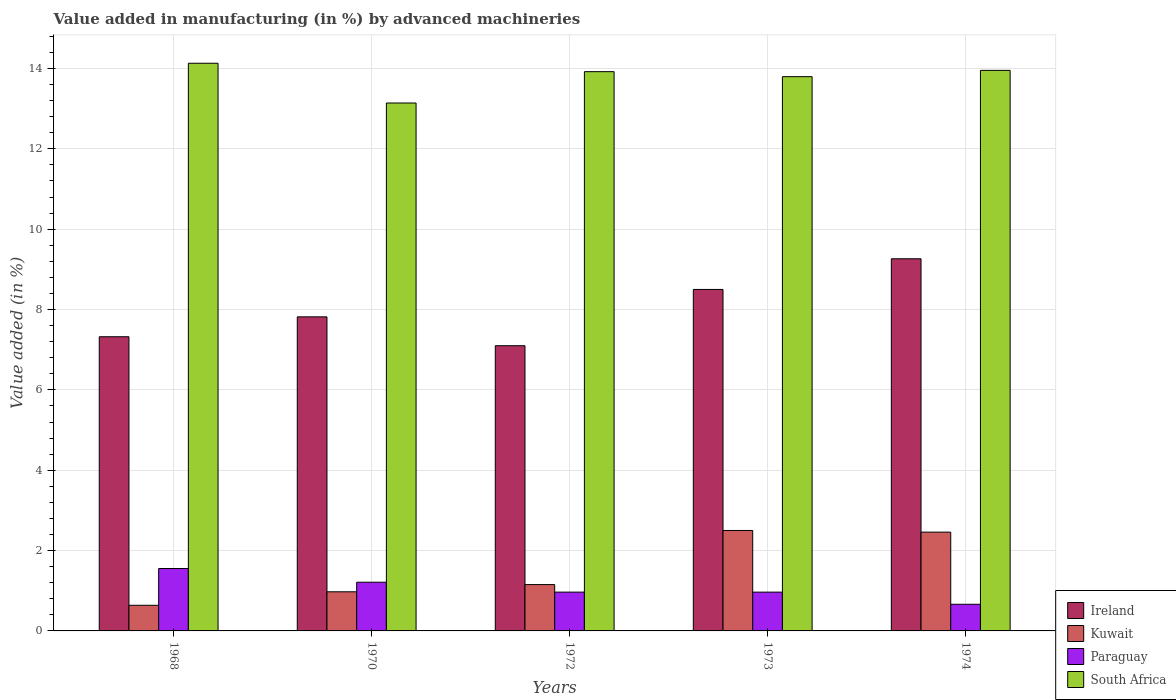How many different coloured bars are there?
Give a very brief answer. 4. Are the number of bars per tick equal to the number of legend labels?
Your answer should be very brief. Yes. How many bars are there on the 4th tick from the right?
Provide a short and direct response. 4. What is the label of the 2nd group of bars from the left?
Your answer should be very brief. 1970. What is the percentage of value added in manufacturing by advanced machineries in Ireland in 1974?
Give a very brief answer. 9.26. Across all years, what is the maximum percentage of value added in manufacturing by advanced machineries in Kuwait?
Offer a very short reply. 2.5. Across all years, what is the minimum percentage of value added in manufacturing by advanced machineries in Kuwait?
Offer a terse response. 0.64. In which year was the percentage of value added in manufacturing by advanced machineries in Paraguay maximum?
Ensure brevity in your answer.  1968. What is the total percentage of value added in manufacturing by advanced machineries in Kuwait in the graph?
Make the answer very short. 7.73. What is the difference between the percentage of value added in manufacturing by advanced machineries in Paraguay in 1968 and that in 1973?
Ensure brevity in your answer.  0.59. What is the difference between the percentage of value added in manufacturing by advanced machineries in Paraguay in 1968 and the percentage of value added in manufacturing by advanced machineries in Kuwait in 1970?
Ensure brevity in your answer.  0.58. What is the average percentage of value added in manufacturing by advanced machineries in Ireland per year?
Give a very brief answer. 8. In the year 1968, what is the difference between the percentage of value added in manufacturing by advanced machineries in Kuwait and percentage of value added in manufacturing by advanced machineries in Ireland?
Give a very brief answer. -6.68. In how many years, is the percentage of value added in manufacturing by advanced machineries in Paraguay greater than 8.8 %?
Your answer should be very brief. 0. What is the ratio of the percentage of value added in manufacturing by advanced machineries in Kuwait in 1970 to that in 1974?
Provide a succinct answer. 0.4. What is the difference between the highest and the second highest percentage of value added in manufacturing by advanced machineries in Paraguay?
Your answer should be very brief. 0.34. What is the difference between the highest and the lowest percentage of value added in manufacturing by advanced machineries in Paraguay?
Your answer should be very brief. 0.89. In how many years, is the percentage of value added in manufacturing by advanced machineries in Kuwait greater than the average percentage of value added in manufacturing by advanced machineries in Kuwait taken over all years?
Keep it short and to the point. 2. Is it the case that in every year, the sum of the percentage of value added in manufacturing by advanced machineries in South Africa and percentage of value added in manufacturing by advanced machineries in Kuwait is greater than the sum of percentage of value added in manufacturing by advanced machineries in Ireland and percentage of value added in manufacturing by advanced machineries in Paraguay?
Offer a very short reply. No. What does the 4th bar from the left in 1970 represents?
Offer a terse response. South Africa. What does the 1st bar from the right in 1973 represents?
Your response must be concise. South Africa. Is it the case that in every year, the sum of the percentage of value added in manufacturing by advanced machineries in Kuwait and percentage of value added in manufacturing by advanced machineries in Ireland is greater than the percentage of value added in manufacturing by advanced machineries in South Africa?
Ensure brevity in your answer.  No. Does the graph contain any zero values?
Provide a short and direct response. No. Does the graph contain grids?
Ensure brevity in your answer.  Yes. How many legend labels are there?
Keep it short and to the point. 4. What is the title of the graph?
Provide a short and direct response. Value added in manufacturing (in %) by advanced machineries. What is the label or title of the Y-axis?
Offer a very short reply. Value added (in %). What is the Value added (in %) in Ireland in 1968?
Keep it short and to the point. 7.32. What is the Value added (in %) of Kuwait in 1968?
Offer a terse response. 0.64. What is the Value added (in %) of Paraguay in 1968?
Offer a terse response. 1.55. What is the Value added (in %) of South Africa in 1968?
Your response must be concise. 14.13. What is the Value added (in %) of Ireland in 1970?
Give a very brief answer. 7.82. What is the Value added (in %) of Kuwait in 1970?
Give a very brief answer. 0.97. What is the Value added (in %) of Paraguay in 1970?
Keep it short and to the point. 1.21. What is the Value added (in %) in South Africa in 1970?
Keep it short and to the point. 13.14. What is the Value added (in %) of Ireland in 1972?
Ensure brevity in your answer.  7.1. What is the Value added (in %) of Kuwait in 1972?
Keep it short and to the point. 1.15. What is the Value added (in %) of Paraguay in 1972?
Keep it short and to the point. 0.97. What is the Value added (in %) in South Africa in 1972?
Offer a very short reply. 13.92. What is the Value added (in %) in Ireland in 1973?
Ensure brevity in your answer.  8.5. What is the Value added (in %) in Kuwait in 1973?
Provide a succinct answer. 2.5. What is the Value added (in %) of Paraguay in 1973?
Keep it short and to the point. 0.97. What is the Value added (in %) of South Africa in 1973?
Your answer should be very brief. 13.8. What is the Value added (in %) in Ireland in 1974?
Offer a very short reply. 9.26. What is the Value added (in %) of Kuwait in 1974?
Make the answer very short. 2.46. What is the Value added (in %) in Paraguay in 1974?
Your answer should be compact. 0.66. What is the Value added (in %) of South Africa in 1974?
Your response must be concise. 13.95. Across all years, what is the maximum Value added (in %) of Ireland?
Your answer should be very brief. 9.26. Across all years, what is the maximum Value added (in %) of Kuwait?
Keep it short and to the point. 2.5. Across all years, what is the maximum Value added (in %) in Paraguay?
Give a very brief answer. 1.55. Across all years, what is the maximum Value added (in %) in South Africa?
Provide a short and direct response. 14.13. Across all years, what is the minimum Value added (in %) in Ireland?
Ensure brevity in your answer.  7.1. Across all years, what is the minimum Value added (in %) in Kuwait?
Give a very brief answer. 0.64. Across all years, what is the minimum Value added (in %) of Paraguay?
Provide a succinct answer. 0.66. Across all years, what is the minimum Value added (in %) in South Africa?
Offer a very short reply. 13.14. What is the total Value added (in %) of Ireland in the graph?
Make the answer very short. 40. What is the total Value added (in %) of Kuwait in the graph?
Keep it short and to the point. 7.72. What is the total Value added (in %) in Paraguay in the graph?
Make the answer very short. 5.36. What is the total Value added (in %) in South Africa in the graph?
Your answer should be very brief. 68.94. What is the difference between the Value added (in %) in Ireland in 1968 and that in 1970?
Keep it short and to the point. -0.5. What is the difference between the Value added (in %) in Kuwait in 1968 and that in 1970?
Provide a succinct answer. -0.34. What is the difference between the Value added (in %) in Paraguay in 1968 and that in 1970?
Make the answer very short. 0.34. What is the difference between the Value added (in %) of South Africa in 1968 and that in 1970?
Give a very brief answer. 0.99. What is the difference between the Value added (in %) in Ireland in 1968 and that in 1972?
Your answer should be very brief. 0.22. What is the difference between the Value added (in %) of Kuwait in 1968 and that in 1972?
Your response must be concise. -0.52. What is the difference between the Value added (in %) in Paraguay in 1968 and that in 1972?
Provide a short and direct response. 0.59. What is the difference between the Value added (in %) of South Africa in 1968 and that in 1972?
Make the answer very short. 0.21. What is the difference between the Value added (in %) in Ireland in 1968 and that in 1973?
Your response must be concise. -1.18. What is the difference between the Value added (in %) of Kuwait in 1968 and that in 1973?
Offer a terse response. -1.86. What is the difference between the Value added (in %) in Paraguay in 1968 and that in 1973?
Make the answer very short. 0.59. What is the difference between the Value added (in %) of South Africa in 1968 and that in 1973?
Ensure brevity in your answer.  0.33. What is the difference between the Value added (in %) of Ireland in 1968 and that in 1974?
Your answer should be very brief. -1.94. What is the difference between the Value added (in %) of Kuwait in 1968 and that in 1974?
Keep it short and to the point. -1.82. What is the difference between the Value added (in %) in Paraguay in 1968 and that in 1974?
Your answer should be very brief. 0.89. What is the difference between the Value added (in %) in South Africa in 1968 and that in 1974?
Provide a short and direct response. 0.18. What is the difference between the Value added (in %) in Ireland in 1970 and that in 1972?
Offer a terse response. 0.72. What is the difference between the Value added (in %) of Kuwait in 1970 and that in 1972?
Your answer should be compact. -0.18. What is the difference between the Value added (in %) of Paraguay in 1970 and that in 1972?
Make the answer very short. 0.25. What is the difference between the Value added (in %) of South Africa in 1970 and that in 1972?
Ensure brevity in your answer.  -0.78. What is the difference between the Value added (in %) of Ireland in 1970 and that in 1973?
Make the answer very short. -0.68. What is the difference between the Value added (in %) of Kuwait in 1970 and that in 1973?
Your response must be concise. -1.53. What is the difference between the Value added (in %) of Paraguay in 1970 and that in 1973?
Offer a very short reply. 0.25. What is the difference between the Value added (in %) of South Africa in 1970 and that in 1973?
Provide a succinct answer. -0.66. What is the difference between the Value added (in %) in Ireland in 1970 and that in 1974?
Ensure brevity in your answer.  -1.45. What is the difference between the Value added (in %) of Kuwait in 1970 and that in 1974?
Your answer should be very brief. -1.49. What is the difference between the Value added (in %) of Paraguay in 1970 and that in 1974?
Give a very brief answer. 0.55. What is the difference between the Value added (in %) in South Africa in 1970 and that in 1974?
Offer a very short reply. -0.81. What is the difference between the Value added (in %) of Ireland in 1972 and that in 1973?
Offer a terse response. -1.4. What is the difference between the Value added (in %) in Kuwait in 1972 and that in 1973?
Your response must be concise. -1.35. What is the difference between the Value added (in %) of Paraguay in 1972 and that in 1973?
Your response must be concise. 0. What is the difference between the Value added (in %) of South Africa in 1972 and that in 1973?
Your answer should be compact. 0.12. What is the difference between the Value added (in %) in Ireland in 1972 and that in 1974?
Offer a very short reply. -2.16. What is the difference between the Value added (in %) of Kuwait in 1972 and that in 1974?
Your answer should be compact. -1.31. What is the difference between the Value added (in %) in Paraguay in 1972 and that in 1974?
Your response must be concise. 0.3. What is the difference between the Value added (in %) of South Africa in 1972 and that in 1974?
Offer a very short reply. -0.03. What is the difference between the Value added (in %) of Ireland in 1973 and that in 1974?
Provide a succinct answer. -0.76. What is the difference between the Value added (in %) in Kuwait in 1973 and that in 1974?
Provide a short and direct response. 0.04. What is the difference between the Value added (in %) of Paraguay in 1973 and that in 1974?
Keep it short and to the point. 0.3. What is the difference between the Value added (in %) in South Africa in 1973 and that in 1974?
Keep it short and to the point. -0.16. What is the difference between the Value added (in %) in Ireland in 1968 and the Value added (in %) in Kuwait in 1970?
Keep it short and to the point. 6.35. What is the difference between the Value added (in %) of Ireland in 1968 and the Value added (in %) of Paraguay in 1970?
Offer a very short reply. 6.11. What is the difference between the Value added (in %) in Ireland in 1968 and the Value added (in %) in South Africa in 1970?
Offer a very short reply. -5.82. What is the difference between the Value added (in %) in Kuwait in 1968 and the Value added (in %) in Paraguay in 1970?
Your answer should be compact. -0.57. What is the difference between the Value added (in %) of Kuwait in 1968 and the Value added (in %) of South Africa in 1970?
Ensure brevity in your answer.  -12.5. What is the difference between the Value added (in %) of Paraguay in 1968 and the Value added (in %) of South Africa in 1970?
Make the answer very short. -11.59. What is the difference between the Value added (in %) in Ireland in 1968 and the Value added (in %) in Kuwait in 1972?
Your answer should be compact. 6.17. What is the difference between the Value added (in %) of Ireland in 1968 and the Value added (in %) of Paraguay in 1972?
Ensure brevity in your answer.  6.36. What is the difference between the Value added (in %) of Ireland in 1968 and the Value added (in %) of South Africa in 1972?
Offer a very short reply. -6.6. What is the difference between the Value added (in %) of Kuwait in 1968 and the Value added (in %) of Paraguay in 1972?
Your answer should be very brief. -0.33. What is the difference between the Value added (in %) of Kuwait in 1968 and the Value added (in %) of South Africa in 1972?
Offer a terse response. -13.28. What is the difference between the Value added (in %) of Paraguay in 1968 and the Value added (in %) of South Africa in 1972?
Keep it short and to the point. -12.37. What is the difference between the Value added (in %) of Ireland in 1968 and the Value added (in %) of Kuwait in 1973?
Your answer should be very brief. 4.82. What is the difference between the Value added (in %) in Ireland in 1968 and the Value added (in %) in Paraguay in 1973?
Provide a short and direct response. 6.36. What is the difference between the Value added (in %) in Ireland in 1968 and the Value added (in %) in South Africa in 1973?
Your answer should be very brief. -6.47. What is the difference between the Value added (in %) in Kuwait in 1968 and the Value added (in %) in Paraguay in 1973?
Ensure brevity in your answer.  -0.33. What is the difference between the Value added (in %) in Kuwait in 1968 and the Value added (in %) in South Africa in 1973?
Provide a succinct answer. -13.16. What is the difference between the Value added (in %) in Paraguay in 1968 and the Value added (in %) in South Africa in 1973?
Provide a short and direct response. -12.24. What is the difference between the Value added (in %) of Ireland in 1968 and the Value added (in %) of Kuwait in 1974?
Your response must be concise. 4.86. What is the difference between the Value added (in %) of Ireland in 1968 and the Value added (in %) of Paraguay in 1974?
Your answer should be compact. 6.66. What is the difference between the Value added (in %) in Ireland in 1968 and the Value added (in %) in South Africa in 1974?
Make the answer very short. -6.63. What is the difference between the Value added (in %) in Kuwait in 1968 and the Value added (in %) in Paraguay in 1974?
Offer a terse response. -0.03. What is the difference between the Value added (in %) in Kuwait in 1968 and the Value added (in %) in South Africa in 1974?
Provide a short and direct response. -13.31. What is the difference between the Value added (in %) of Paraguay in 1968 and the Value added (in %) of South Africa in 1974?
Provide a short and direct response. -12.4. What is the difference between the Value added (in %) in Ireland in 1970 and the Value added (in %) in Kuwait in 1972?
Offer a very short reply. 6.66. What is the difference between the Value added (in %) in Ireland in 1970 and the Value added (in %) in Paraguay in 1972?
Your response must be concise. 6.85. What is the difference between the Value added (in %) in Ireland in 1970 and the Value added (in %) in South Africa in 1972?
Ensure brevity in your answer.  -6.1. What is the difference between the Value added (in %) in Kuwait in 1970 and the Value added (in %) in Paraguay in 1972?
Your answer should be compact. 0.01. What is the difference between the Value added (in %) of Kuwait in 1970 and the Value added (in %) of South Africa in 1972?
Provide a short and direct response. -12.95. What is the difference between the Value added (in %) in Paraguay in 1970 and the Value added (in %) in South Africa in 1972?
Your response must be concise. -12.71. What is the difference between the Value added (in %) in Ireland in 1970 and the Value added (in %) in Kuwait in 1973?
Make the answer very short. 5.32. What is the difference between the Value added (in %) of Ireland in 1970 and the Value added (in %) of Paraguay in 1973?
Your answer should be very brief. 6.85. What is the difference between the Value added (in %) in Ireland in 1970 and the Value added (in %) in South Africa in 1973?
Your answer should be very brief. -5.98. What is the difference between the Value added (in %) in Kuwait in 1970 and the Value added (in %) in Paraguay in 1973?
Offer a terse response. 0.01. What is the difference between the Value added (in %) in Kuwait in 1970 and the Value added (in %) in South Africa in 1973?
Give a very brief answer. -12.82. What is the difference between the Value added (in %) of Paraguay in 1970 and the Value added (in %) of South Africa in 1973?
Provide a short and direct response. -12.58. What is the difference between the Value added (in %) of Ireland in 1970 and the Value added (in %) of Kuwait in 1974?
Offer a very short reply. 5.36. What is the difference between the Value added (in %) in Ireland in 1970 and the Value added (in %) in Paraguay in 1974?
Your response must be concise. 7.15. What is the difference between the Value added (in %) of Ireland in 1970 and the Value added (in %) of South Africa in 1974?
Make the answer very short. -6.13. What is the difference between the Value added (in %) of Kuwait in 1970 and the Value added (in %) of Paraguay in 1974?
Give a very brief answer. 0.31. What is the difference between the Value added (in %) in Kuwait in 1970 and the Value added (in %) in South Africa in 1974?
Ensure brevity in your answer.  -12.98. What is the difference between the Value added (in %) in Paraguay in 1970 and the Value added (in %) in South Africa in 1974?
Offer a very short reply. -12.74. What is the difference between the Value added (in %) of Ireland in 1972 and the Value added (in %) of Kuwait in 1973?
Your answer should be compact. 4.6. What is the difference between the Value added (in %) in Ireland in 1972 and the Value added (in %) in Paraguay in 1973?
Make the answer very short. 6.13. What is the difference between the Value added (in %) of Ireland in 1972 and the Value added (in %) of South Africa in 1973?
Provide a succinct answer. -6.7. What is the difference between the Value added (in %) of Kuwait in 1972 and the Value added (in %) of Paraguay in 1973?
Ensure brevity in your answer.  0.19. What is the difference between the Value added (in %) in Kuwait in 1972 and the Value added (in %) in South Africa in 1973?
Provide a short and direct response. -12.64. What is the difference between the Value added (in %) in Paraguay in 1972 and the Value added (in %) in South Africa in 1973?
Offer a very short reply. -12.83. What is the difference between the Value added (in %) of Ireland in 1972 and the Value added (in %) of Kuwait in 1974?
Your response must be concise. 4.64. What is the difference between the Value added (in %) of Ireland in 1972 and the Value added (in %) of Paraguay in 1974?
Your answer should be very brief. 6.44. What is the difference between the Value added (in %) in Ireland in 1972 and the Value added (in %) in South Africa in 1974?
Your answer should be compact. -6.85. What is the difference between the Value added (in %) of Kuwait in 1972 and the Value added (in %) of Paraguay in 1974?
Your answer should be very brief. 0.49. What is the difference between the Value added (in %) in Kuwait in 1972 and the Value added (in %) in South Africa in 1974?
Keep it short and to the point. -12.8. What is the difference between the Value added (in %) in Paraguay in 1972 and the Value added (in %) in South Africa in 1974?
Offer a very short reply. -12.99. What is the difference between the Value added (in %) in Ireland in 1973 and the Value added (in %) in Kuwait in 1974?
Make the answer very short. 6.04. What is the difference between the Value added (in %) of Ireland in 1973 and the Value added (in %) of Paraguay in 1974?
Your answer should be very brief. 7.84. What is the difference between the Value added (in %) of Ireland in 1973 and the Value added (in %) of South Africa in 1974?
Make the answer very short. -5.45. What is the difference between the Value added (in %) in Kuwait in 1973 and the Value added (in %) in Paraguay in 1974?
Provide a succinct answer. 1.84. What is the difference between the Value added (in %) in Kuwait in 1973 and the Value added (in %) in South Africa in 1974?
Provide a short and direct response. -11.45. What is the difference between the Value added (in %) in Paraguay in 1973 and the Value added (in %) in South Africa in 1974?
Provide a short and direct response. -12.99. What is the average Value added (in %) in Ireland per year?
Your answer should be very brief. 8. What is the average Value added (in %) of Kuwait per year?
Your response must be concise. 1.54. What is the average Value added (in %) of Paraguay per year?
Make the answer very short. 1.07. What is the average Value added (in %) of South Africa per year?
Your response must be concise. 13.79. In the year 1968, what is the difference between the Value added (in %) in Ireland and Value added (in %) in Kuwait?
Your answer should be compact. 6.68. In the year 1968, what is the difference between the Value added (in %) in Ireland and Value added (in %) in Paraguay?
Give a very brief answer. 5.77. In the year 1968, what is the difference between the Value added (in %) of Ireland and Value added (in %) of South Africa?
Your response must be concise. -6.81. In the year 1968, what is the difference between the Value added (in %) of Kuwait and Value added (in %) of Paraguay?
Provide a succinct answer. -0.92. In the year 1968, what is the difference between the Value added (in %) in Kuwait and Value added (in %) in South Africa?
Your answer should be compact. -13.49. In the year 1968, what is the difference between the Value added (in %) of Paraguay and Value added (in %) of South Africa?
Your answer should be compact. -12.58. In the year 1970, what is the difference between the Value added (in %) in Ireland and Value added (in %) in Kuwait?
Provide a short and direct response. 6.84. In the year 1970, what is the difference between the Value added (in %) in Ireland and Value added (in %) in Paraguay?
Provide a short and direct response. 6.61. In the year 1970, what is the difference between the Value added (in %) in Ireland and Value added (in %) in South Africa?
Offer a terse response. -5.32. In the year 1970, what is the difference between the Value added (in %) of Kuwait and Value added (in %) of Paraguay?
Give a very brief answer. -0.24. In the year 1970, what is the difference between the Value added (in %) of Kuwait and Value added (in %) of South Africa?
Keep it short and to the point. -12.17. In the year 1970, what is the difference between the Value added (in %) in Paraguay and Value added (in %) in South Africa?
Offer a very short reply. -11.93. In the year 1972, what is the difference between the Value added (in %) in Ireland and Value added (in %) in Kuwait?
Offer a terse response. 5.95. In the year 1972, what is the difference between the Value added (in %) in Ireland and Value added (in %) in Paraguay?
Your answer should be very brief. 6.13. In the year 1972, what is the difference between the Value added (in %) in Ireland and Value added (in %) in South Africa?
Your response must be concise. -6.82. In the year 1972, what is the difference between the Value added (in %) of Kuwait and Value added (in %) of Paraguay?
Make the answer very short. 0.19. In the year 1972, what is the difference between the Value added (in %) in Kuwait and Value added (in %) in South Africa?
Your answer should be compact. -12.77. In the year 1972, what is the difference between the Value added (in %) of Paraguay and Value added (in %) of South Africa?
Provide a short and direct response. -12.95. In the year 1973, what is the difference between the Value added (in %) in Ireland and Value added (in %) in Kuwait?
Offer a terse response. 6. In the year 1973, what is the difference between the Value added (in %) of Ireland and Value added (in %) of Paraguay?
Your response must be concise. 7.53. In the year 1973, what is the difference between the Value added (in %) of Ireland and Value added (in %) of South Africa?
Give a very brief answer. -5.3. In the year 1973, what is the difference between the Value added (in %) of Kuwait and Value added (in %) of Paraguay?
Ensure brevity in your answer.  1.53. In the year 1973, what is the difference between the Value added (in %) in Kuwait and Value added (in %) in South Africa?
Offer a very short reply. -11.3. In the year 1973, what is the difference between the Value added (in %) in Paraguay and Value added (in %) in South Africa?
Provide a short and direct response. -12.83. In the year 1974, what is the difference between the Value added (in %) of Ireland and Value added (in %) of Kuwait?
Ensure brevity in your answer.  6.8. In the year 1974, what is the difference between the Value added (in %) of Ireland and Value added (in %) of Paraguay?
Ensure brevity in your answer.  8.6. In the year 1974, what is the difference between the Value added (in %) in Ireland and Value added (in %) in South Africa?
Give a very brief answer. -4.69. In the year 1974, what is the difference between the Value added (in %) in Kuwait and Value added (in %) in Paraguay?
Your answer should be very brief. 1.8. In the year 1974, what is the difference between the Value added (in %) in Kuwait and Value added (in %) in South Africa?
Provide a succinct answer. -11.49. In the year 1974, what is the difference between the Value added (in %) in Paraguay and Value added (in %) in South Africa?
Offer a very short reply. -13.29. What is the ratio of the Value added (in %) in Ireland in 1968 to that in 1970?
Offer a very short reply. 0.94. What is the ratio of the Value added (in %) in Kuwait in 1968 to that in 1970?
Your response must be concise. 0.66. What is the ratio of the Value added (in %) of Paraguay in 1968 to that in 1970?
Give a very brief answer. 1.28. What is the ratio of the Value added (in %) of South Africa in 1968 to that in 1970?
Your answer should be compact. 1.08. What is the ratio of the Value added (in %) of Ireland in 1968 to that in 1972?
Your answer should be very brief. 1.03. What is the ratio of the Value added (in %) of Kuwait in 1968 to that in 1972?
Provide a short and direct response. 0.55. What is the ratio of the Value added (in %) in Paraguay in 1968 to that in 1972?
Offer a very short reply. 1.61. What is the ratio of the Value added (in %) in South Africa in 1968 to that in 1972?
Your answer should be very brief. 1.01. What is the ratio of the Value added (in %) of Ireland in 1968 to that in 1973?
Your response must be concise. 0.86. What is the ratio of the Value added (in %) of Kuwait in 1968 to that in 1973?
Provide a succinct answer. 0.26. What is the ratio of the Value added (in %) of Paraguay in 1968 to that in 1973?
Offer a very short reply. 1.61. What is the ratio of the Value added (in %) of South Africa in 1968 to that in 1973?
Make the answer very short. 1.02. What is the ratio of the Value added (in %) of Ireland in 1968 to that in 1974?
Your answer should be compact. 0.79. What is the ratio of the Value added (in %) in Kuwait in 1968 to that in 1974?
Provide a succinct answer. 0.26. What is the ratio of the Value added (in %) of Paraguay in 1968 to that in 1974?
Give a very brief answer. 2.34. What is the ratio of the Value added (in %) of South Africa in 1968 to that in 1974?
Keep it short and to the point. 1.01. What is the ratio of the Value added (in %) of Ireland in 1970 to that in 1972?
Your response must be concise. 1.1. What is the ratio of the Value added (in %) of Kuwait in 1970 to that in 1972?
Keep it short and to the point. 0.84. What is the ratio of the Value added (in %) of Paraguay in 1970 to that in 1972?
Ensure brevity in your answer.  1.26. What is the ratio of the Value added (in %) of South Africa in 1970 to that in 1972?
Keep it short and to the point. 0.94. What is the ratio of the Value added (in %) in Ireland in 1970 to that in 1973?
Your answer should be compact. 0.92. What is the ratio of the Value added (in %) of Kuwait in 1970 to that in 1973?
Ensure brevity in your answer.  0.39. What is the ratio of the Value added (in %) of Paraguay in 1970 to that in 1973?
Provide a succinct answer. 1.26. What is the ratio of the Value added (in %) in South Africa in 1970 to that in 1973?
Your response must be concise. 0.95. What is the ratio of the Value added (in %) in Ireland in 1970 to that in 1974?
Keep it short and to the point. 0.84. What is the ratio of the Value added (in %) in Kuwait in 1970 to that in 1974?
Ensure brevity in your answer.  0.4. What is the ratio of the Value added (in %) in Paraguay in 1970 to that in 1974?
Your answer should be compact. 1.83. What is the ratio of the Value added (in %) of South Africa in 1970 to that in 1974?
Provide a short and direct response. 0.94. What is the ratio of the Value added (in %) in Ireland in 1972 to that in 1973?
Give a very brief answer. 0.84. What is the ratio of the Value added (in %) in Kuwait in 1972 to that in 1973?
Offer a terse response. 0.46. What is the ratio of the Value added (in %) in Ireland in 1972 to that in 1974?
Offer a terse response. 0.77. What is the ratio of the Value added (in %) of Kuwait in 1972 to that in 1974?
Offer a very short reply. 0.47. What is the ratio of the Value added (in %) in Paraguay in 1972 to that in 1974?
Make the answer very short. 1.46. What is the ratio of the Value added (in %) in Ireland in 1973 to that in 1974?
Offer a terse response. 0.92. What is the ratio of the Value added (in %) of Kuwait in 1973 to that in 1974?
Your response must be concise. 1.02. What is the ratio of the Value added (in %) of Paraguay in 1973 to that in 1974?
Provide a short and direct response. 1.46. What is the difference between the highest and the second highest Value added (in %) of Ireland?
Keep it short and to the point. 0.76. What is the difference between the highest and the second highest Value added (in %) of Kuwait?
Offer a terse response. 0.04. What is the difference between the highest and the second highest Value added (in %) of Paraguay?
Your response must be concise. 0.34. What is the difference between the highest and the second highest Value added (in %) of South Africa?
Ensure brevity in your answer.  0.18. What is the difference between the highest and the lowest Value added (in %) in Ireland?
Offer a very short reply. 2.16. What is the difference between the highest and the lowest Value added (in %) in Kuwait?
Make the answer very short. 1.86. What is the difference between the highest and the lowest Value added (in %) in Paraguay?
Your answer should be compact. 0.89. What is the difference between the highest and the lowest Value added (in %) of South Africa?
Provide a succinct answer. 0.99. 